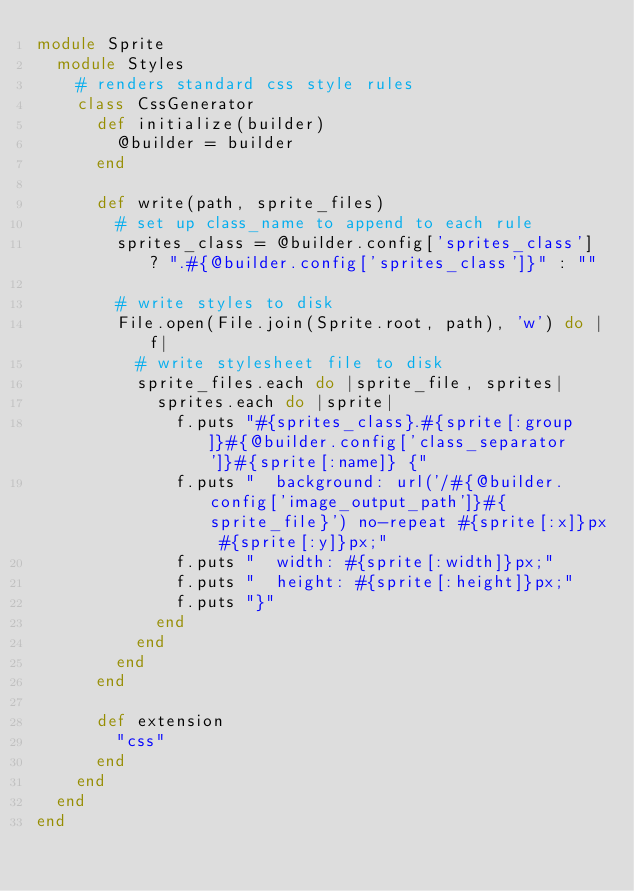Convert code to text. <code><loc_0><loc_0><loc_500><loc_500><_Ruby_>module Sprite
  module Styles
    # renders standard css style rules
    class CssGenerator
      def initialize(builder)
        @builder = builder
      end
  
      def write(path, sprite_files)
        # set up class_name to append to each rule
        sprites_class = @builder.config['sprites_class'] ? ".#{@builder.config['sprites_class']}" : ""
    
        # write styles to disk
        File.open(File.join(Sprite.root, path), 'w') do |f|
          # write stylesheet file to disk
          sprite_files.each do |sprite_file, sprites|
            sprites.each do |sprite|
              f.puts "#{sprites_class}.#{sprite[:group]}#{@builder.config['class_separator']}#{sprite[:name]} {"
              f.puts "  background: url('/#{@builder.config['image_output_path']}#{sprite_file}') no-repeat #{sprite[:x]}px #{sprite[:y]}px;"
              f.puts "  width: #{sprite[:width]}px;"
              f.puts "  height: #{sprite[:height]}px;"
              f.puts "}"
            end
          end
        end      
      end
  
      def extension
        "css"
      end
    end
  end
end</code> 